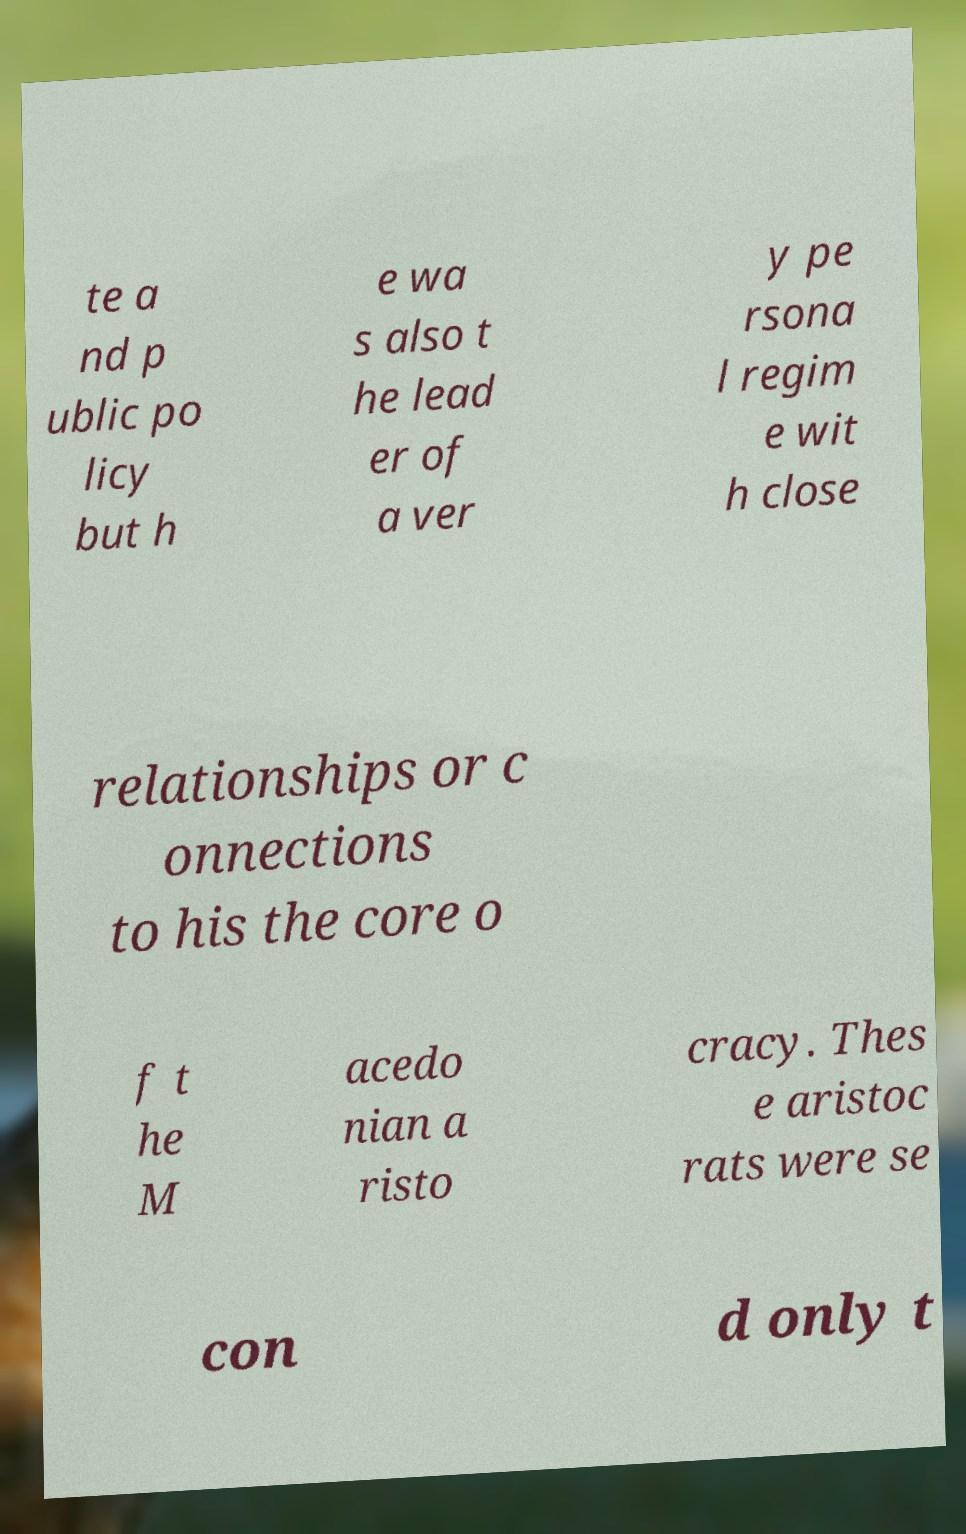Can you read and provide the text displayed in the image?This photo seems to have some interesting text. Can you extract and type it out for me? te a nd p ublic po licy but h e wa s also t he lead er of a ver y pe rsona l regim e wit h close relationships or c onnections to his the core o f t he M acedo nian a risto cracy. Thes e aristoc rats were se con d only t 